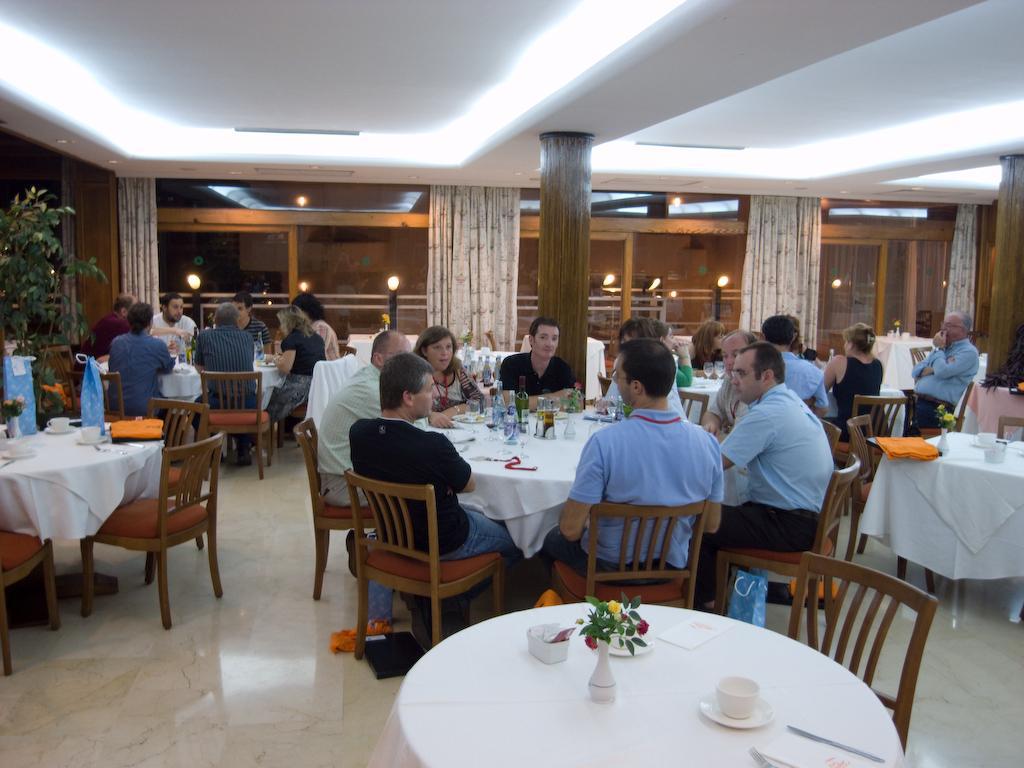Can you describe this image briefly? this picture shows group of people seated on the chairs and we see few bottles and cups on the table and we see few curtains hanging to the windows and we see a plant 